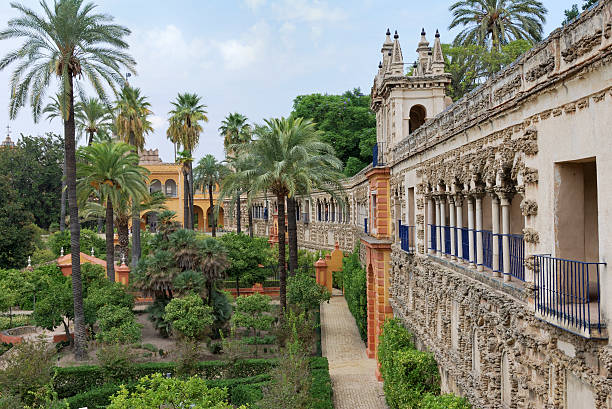Can you tell me more about the architecture visible in the garden? The architecture framed by the lush greenery in the gardens is a fine example of Spanish Renaissance style, characterized by intricate stone carvings and ornamental detailing. These buildings, part of the Alcazar of Seville, serve as a testament to the city's historical depth and artistic heritage, blending elements from Christian and Moorish influences to create a visually stunning aesthetic. The arches and columns are particularly noteworthy, adorned with motifs that reflect the cultural interplay that is a hallmark of Andalusian architecture. 